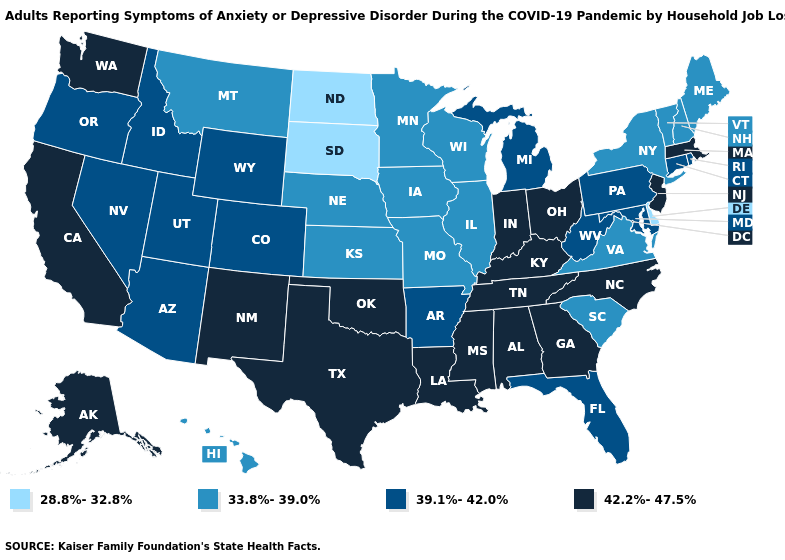What is the value of West Virginia?
Answer briefly. 39.1%-42.0%. Among the states that border Missouri , which have the lowest value?
Give a very brief answer. Illinois, Iowa, Kansas, Nebraska. What is the value of Massachusetts?
Concise answer only. 42.2%-47.5%. What is the value of Indiana?
Be succinct. 42.2%-47.5%. What is the value of Massachusetts?
Give a very brief answer. 42.2%-47.5%. What is the value of Indiana?
Write a very short answer. 42.2%-47.5%. Name the states that have a value in the range 39.1%-42.0%?
Keep it brief. Arizona, Arkansas, Colorado, Connecticut, Florida, Idaho, Maryland, Michigan, Nevada, Oregon, Pennsylvania, Rhode Island, Utah, West Virginia, Wyoming. Does the first symbol in the legend represent the smallest category?
Be succinct. Yes. How many symbols are there in the legend?
Write a very short answer. 4. What is the value of Wisconsin?
Concise answer only. 33.8%-39.0%. Does Kentucky have the same value as Iowa?
Concise answer only. No. Is the legend a continuous bar?
Write a very short answer. No. Does New Hampshire have the same value as Vermont?
Short answer required. Yes. What is the lowest value in the MidWest?
Keep it brief. 28.8%-32.8%. Name the states that have a value in the range 39.1%-42.0%?
Keep it brief. Arizona, Arkansas, Colorado, Connecticut, Florida, Idaho, Maryland, Michigan, Nevada, Oregon, Pennsylvania, Rhode Island, Utah, West Virginia, Wyoming. 